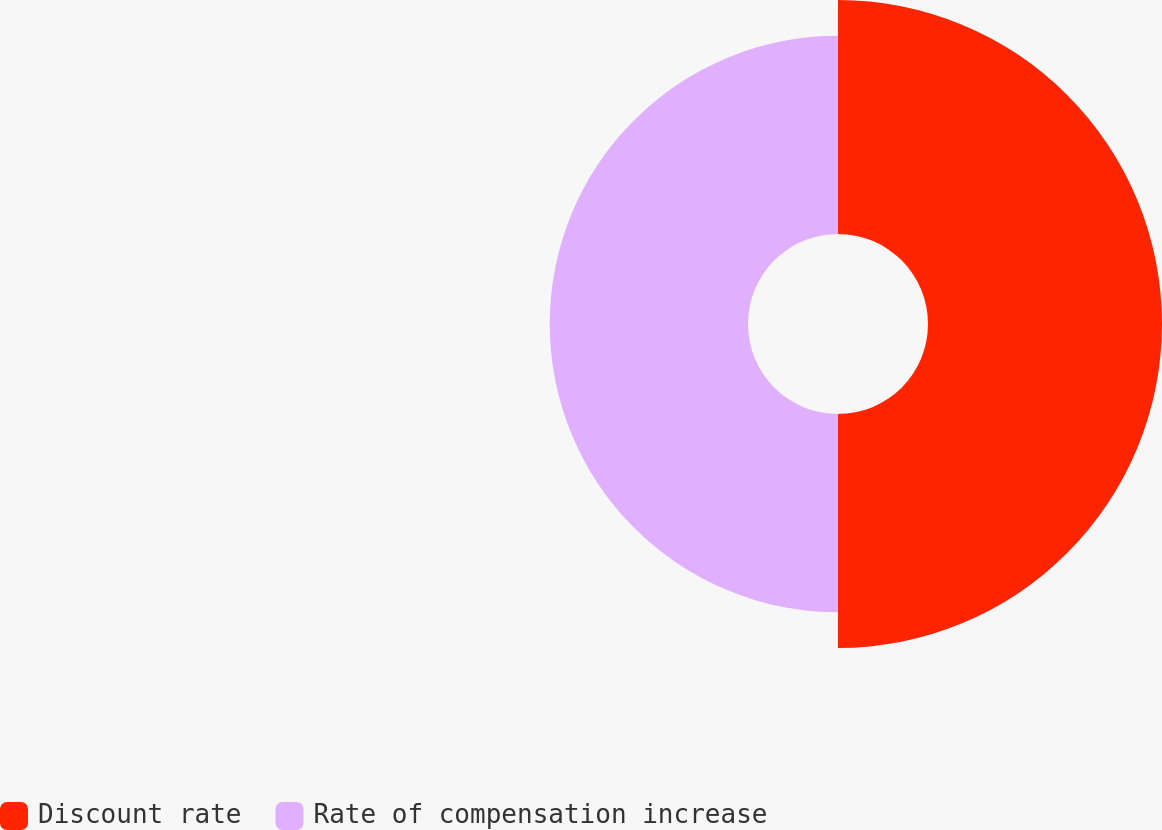Convert chart to OTSL. <chart><loc_0><loc_0><loc_500><loc_500><pie_chart><fcel>Discount rate<fcel>Rate of compensation increase<nl><fcel>54.13%<fcel>45.87%<nl></chart> 